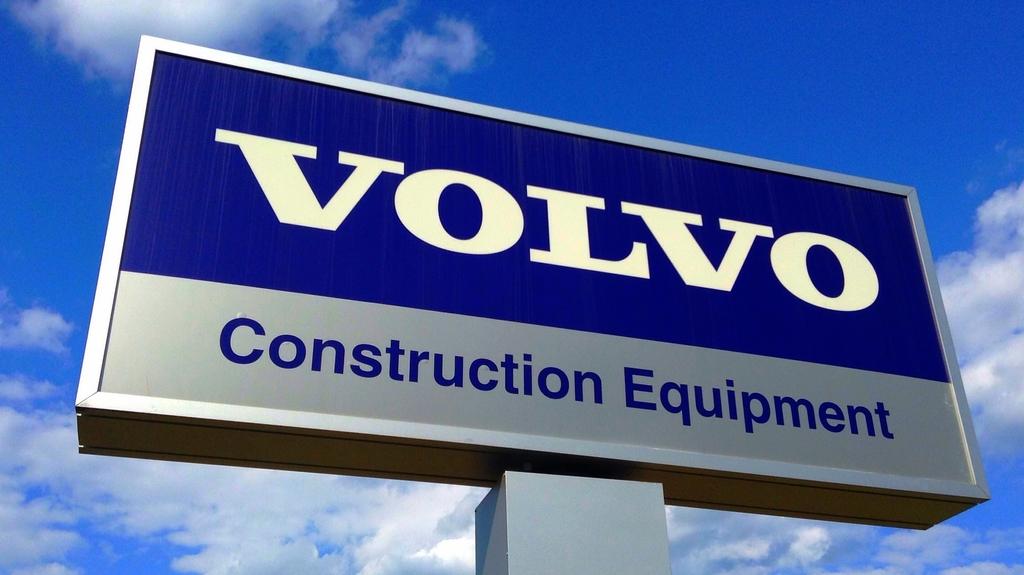What specifically is volvo selling here?
Keep it short and to the point. Construction equipment. What company is this sign for?
Make the answer very short. Volvo. 